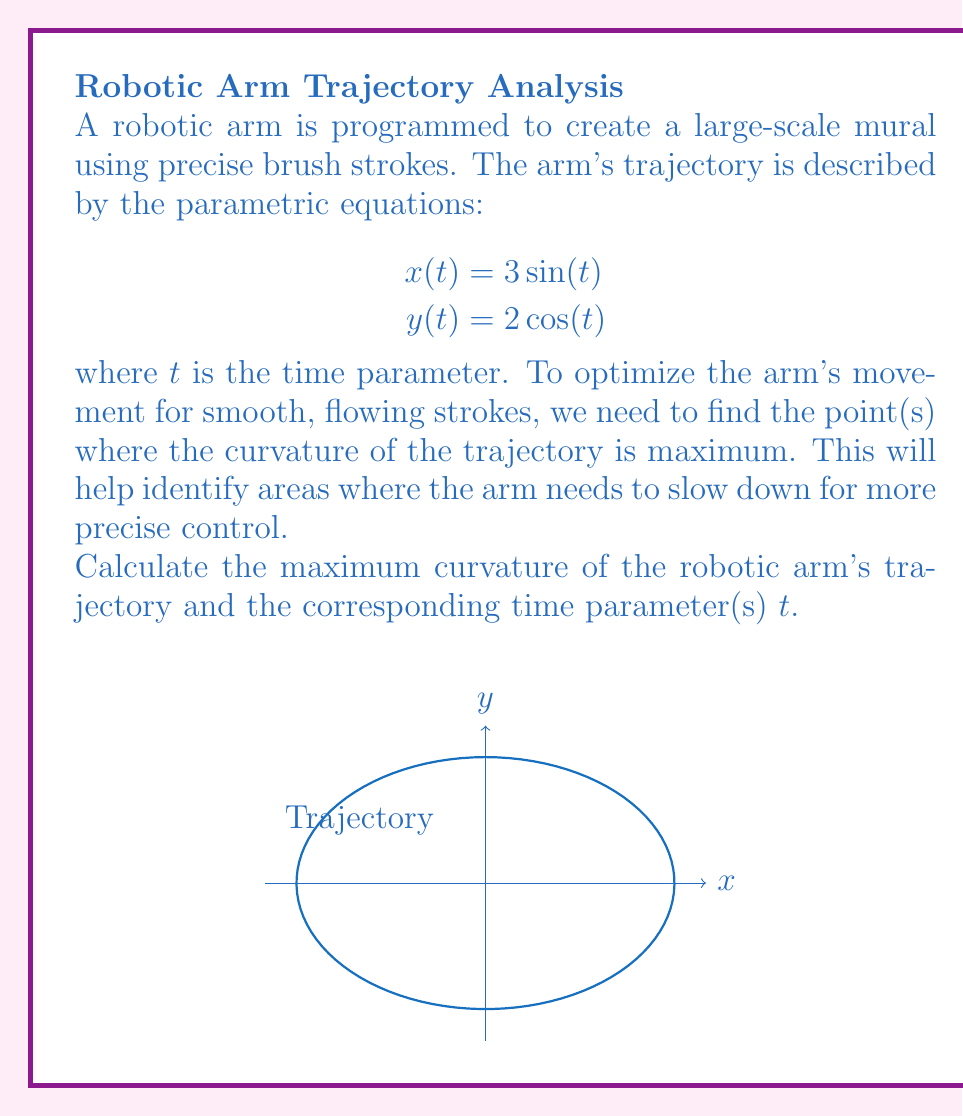Provide a solution to this math problem. To solve this problem, we'll follow these steps:

1) The curvature $\kappa$ of a parametric curve is given by:

   $$\kappa = \frac{|\dot{x}\ddot{y} - \dot{y}\ddot{x}|}{(\dot{x}^2 + \dot{y}^2)^{3/2}}$$

2) Calculate the first and second derivatives:
   $$\dot{x} = 3\cos(t), \quad \ddot{x} = -3\sin(t)$$
   $$\dot{y} = -2\sin(t), \quad \ddot{y} = -2\cos(t)$$

3) Substitute into the curvature formula:

   $$\kappa = \frac{|3\cos(t)(-2\cos(t)) - (-2\sin(t))(-3\sin(t))|}{(9\cos^2(t) + 4\sin^2(t))^{3/2}}$$

4) Simplify:

   $$\kappa = \frac{|-6\cos^2(t) - 6\sin^2(t)|}{(9\cos^2(t) + 4\sin^2(t))^{3/2}} = \frac{6}{(9\cos^2(t) + 4\sin^2(t))^{3/2}}$$

5) To find the maximum curvature, we need to minimize the denominator. The denominator is minimum when $\cos^2(t)$ is at its minimum (0) and $\sin^2(t)$ is at its maximum (1), or vice versa.

6) This occurs when $t = \frac{\pi}{2}$ or $t = \frac{3\pi}{2}$.

7) The maximum curvature is thus:

   $$\kappa_{max} = \frac{6}{(4)^{3/2}} = \frac{3}{4}$$

This occurs at $t = \frac{\pi}{2}$ and $t = \frac{3\pi}{2}$, corresponding to the points $(0, \pm 2)$ on the trajectory.
Answer: Maximum curvature: $\frac{3}{4}$; at $t = \frac{\pi}{2}$ and $t = \frac{3\pi}{2}$ 